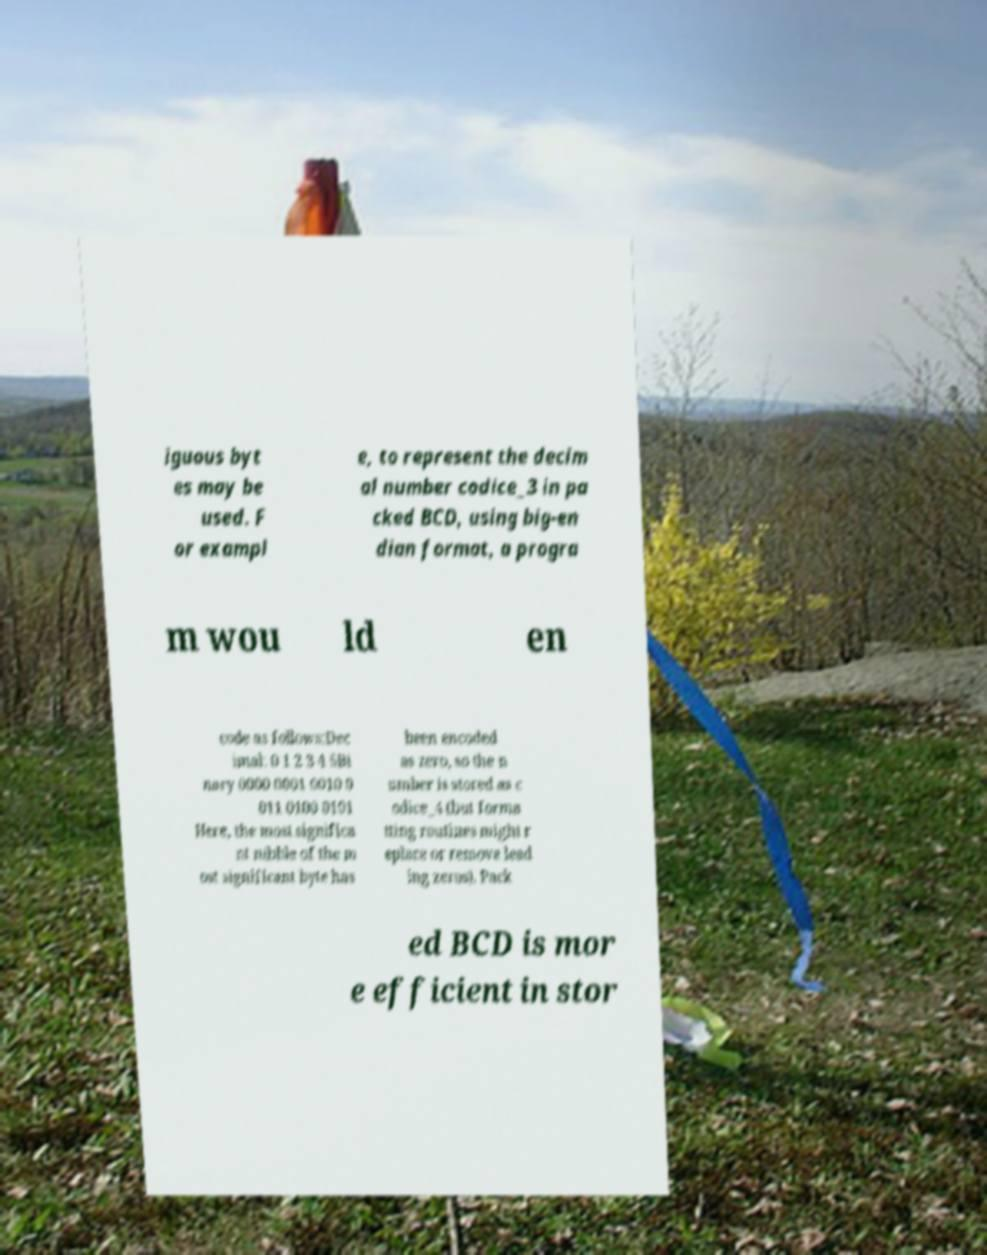What messages or text are displayed in this image? I need them in a readable, typed format. iguous byt es may be used. F or exampl e, to represent the decim al number codice_3 in pa cked BCD, using big-en dian format, a progra m wou ld en code as follows:Dec imal: 0 1 2 3 4 5Bi nary 0000 0001 0010 0 011 0100 0101 Here, the most significa nt nibble of the m ost significant byte has been encoded as zero, so the n umber is stored as c odice_4 (but forma tting routines might r eplace or remove lead ing zeros). Pack ed BCD is mor e efficient in stor 